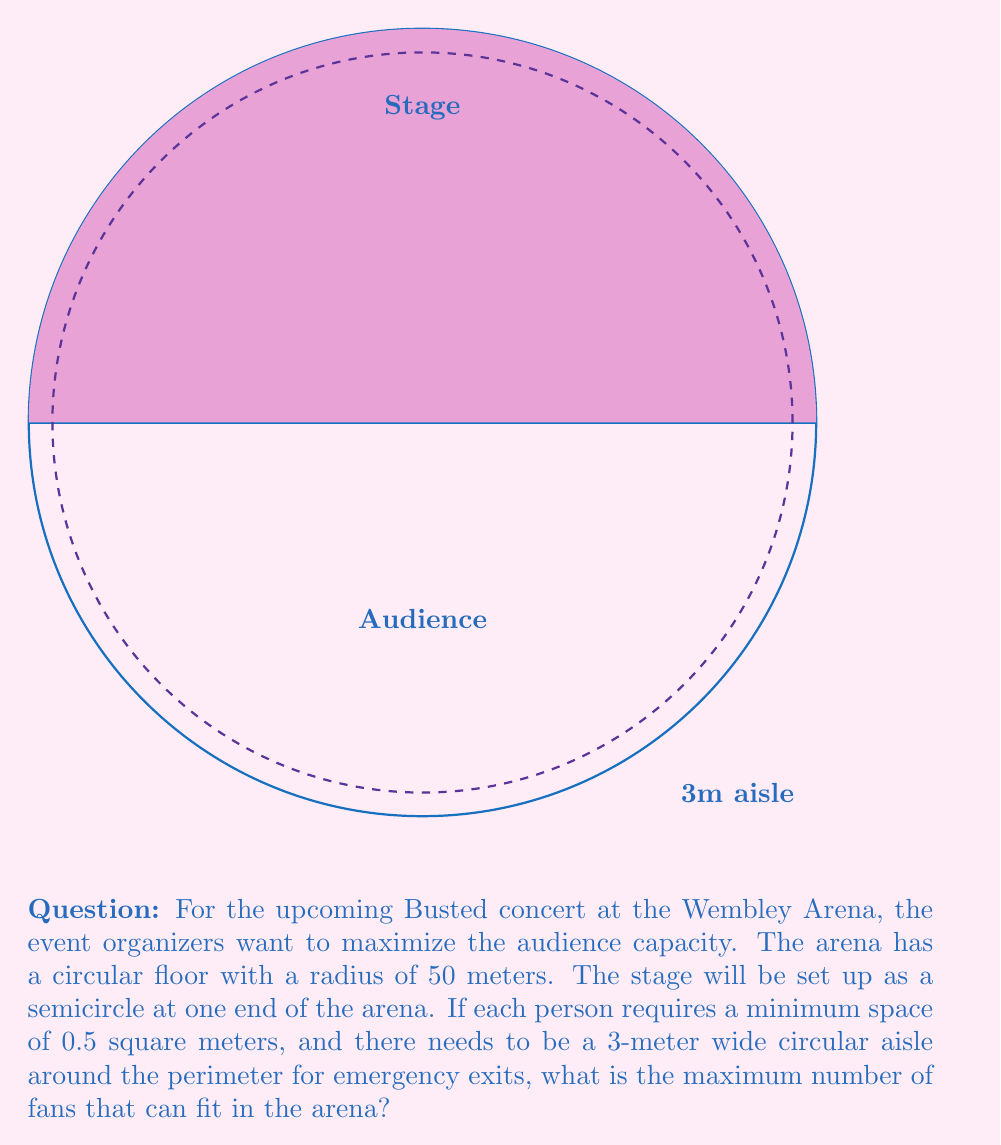Could you help me with this problem? Let's approach this step-by-step:

1) First, we need to calculate the total area of the arena:
   $$A_{total} = \pi r^2 = \pi (50^2) = 7853.98 \text{ m}^2$$

2) The stage is a semicircle, so its area is:
   $$A_{stage} = \frac{1}{2} \pi r^2 = \frac{1}{2} \pi (50^2) = 3926.99 \text{ m}^2$$

3) The area of the 3-meter wide aisle is:
   $$A_{aisle} = \pi (50^2) - \pi (47^2) = 7853.98 - 6939.78 = 914.20 \text{ m}^2$$

4) The available area for the audience is:
   $$A_{audience} = A_{total} - A_{stage} - A_{aisle}$$
   $$A_{audience} = 7853.98 - 3926.99 - 914.20 = 3012.79 \text{ m}^2$$

5) Each person requires 0.5 square meters, so the maximum number of fans is:
   $$N_{fans} = \frac{A_{audience}}{0.5} = \frac{3012.79}{0.5} = 6025.58$$

6) Since we can't have a fraction of a person, we round down to the nearest whole number.
Answer: 6025 fans 